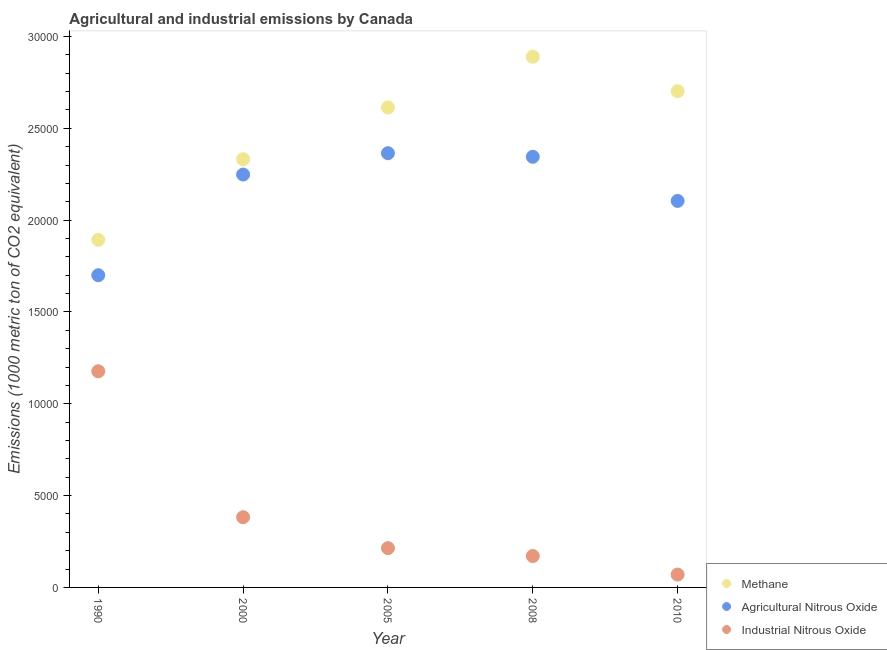How many different coloured dotlines are there?
Your answer should be compact. 3. What is the amount of methane emissions in 2005?
Make the answer very short. 2.61e+04. Across all years, what is the maximum amount of agricultural nitrous oxide emissions?
Your response must be concise. 2.36e+04. Across all years, what is the minimum amount of agricultural nitrous oxide emissions?
Provide a short and direct response. 1.70e+04. In which year was the amount of methane emissions maximum?
Provide a succinct answer. 2008. What is the total amount of industrial nitrous oxide emissions in the graph?
Your answer should be very brief. 2.01e+04. What is the difference between the amount of industrial nitrous oxide emissions in 2000 and that in 2010?
Provide a succinct answer. 3122.5. What is the difference between the amount of industrial nitrous oxide emissions in 1990 and the amount of agricultural nitrous oxide emissions in 2000?
Provide a succinct answer. -1.07e+04. What is the average amount of methane emissions per year?
Make the answer very short. 2.49e+04. In the year 2010, what is the difference between the amount of methane emissions and amount of industrial nitrous oxide emissions?
Your answer should be compact. 2.63e+04. What is the ratio of the amount of industrial nitrous oxide emissions in 2008 to that in 2010?
Keep it short and to the point. 2.44. Is the difference between the amount of agricultural nitrous oxide emissions in 2005 and 2010 greater than the difference between the amount of industrial nitrous oxide emissions in 2005 and 2010?
Ensure brevity in your answer.  Yes. What is the difference between the highest and the second highest amount of agricultural nitrous oxide emissions?
Make the answer very short. 193.7. What is the difference between the highest and the lowest amount of industrial nitrous oxide emissions?
Provide a succinct answer. 1.11e+04. In how many years, is the amount of industrial nitrous oxide emissions greater than the average amount of industrial nitrous oxide emissions taken over all years?
Your answer should be compact. 1. Is the sum of the amount of methane emissions in 2005 and 2010 greater than the maximum amount of industrial nitrous oxide emissions across all years?
Provide a succinct answer. Yes. Does the amount of industrial nitrous oxide emissions monotonically increase over the years?
Ensure brevity in your answer.  No. Is the amount of agricultural nitrous oxide emissions strictly greater than the amount of industrial nitrous oxide emissions over the years?
Offer a very short reply. Yes. How many years are there in the graph?
Make the answer very short. 5. What is the title of the graph?
Keep it short and to the point. Agricultural and industrial emissions by Canada. Does "Social Insurance" appear as one of the legend labels in the graph?
Make the answer very short. No. What is the label or title of the Y-axis?
Make the answer very short. Emissions (1000 metric ton of CO2 equivalent). What is the Emissions (1000 metric ton of CO2 equivalent) in Methane in 1990?
Your answer should be very brief. 1.89e+04. What is the Emissions (1000 metric ton of CO2 equivalent) of Agricultural Nitrous Oxide in 1990?
Make the answer very short. 1.70e+04. What is the Emissions (1000 metric ton of CO2 equivalent) of Industrial Nitrous Oxide in 1990?
Ensure brevity in your answer.  1.18e+04. What is the Emissions (1000 metric ton of CO2 equivalent) of Methane in 2000?
Ensure brevity in your answer.  2.33e+04. What is the Emissions (1000 metric ton of CO2 equivalent) in Agricultural Nitrous Oxide in 2000?
Keep it short and to the point. 2.25e+04. What is the Emissions (1000 metric ton of CO2 equivalent) in Industrial Nitrous Oxide in 2000?
Give a very brief answer. 3823.3. What is the Emissions (1000 metric ton of CO2 equivalent) of Methane in 2005?
Make the answer very short. 2.61e+04. What is the Emissions (1000 metric ton of CO2 equivalent) of Agricultural Nitrous Oxide in 2005?
Your response must be concise. 2.36e+04. What is the Emissions (1000 metric ton of CO2 equivalent) in Industrial Nitrous Oxide in 2005?
Provide a short and direct response. 2139.7. What is the Emissions (1000 metric ton of CO2 equivalent) of Methane in 2008?
Your answer should be compact. 2.89e+04. What is the Emissions (1000 metric ton of CO2 equivalent) in Agricultural Nitrous Oxide in 2008?
Your response must be concise. 2.34e+04. What is the Emissions (1000 metric ton of CO2 equivalent) of Industrial Nitrous Oxide in 2008?
Make the answer very short. 1709.6. What is the Emissions (1000 metric ton of CO2 equivalent) of Methane in 2010?
Ensure brevity in your answer.  2.70e+04. What is the Emissions (1000 metric ton of CO2 equivalent) in Agricultural Nitrous Oxide in 2010?
Offer a terse response. 2.10e+04. What is the Emissions (1000 metric ton of CO2 equivalent) in Industrial Nitrous Oxide in 2010?
Keep it short and to the point. 700.8. Across all years, what is the maximum Emissions (1000 metric ton of CO2 equivalent) of Methane?
Your answer should be compact. 2.89e+04. Across all years, what is the maximum Emissions (1000 metric ton of CO2 equivalent) in Agricultural Nitrous Oxide?
Keep it short and to the point. 2.36e+04. Across all years, what is the maximum Emissions (1000 metric ton of CO2 equivalent) in Industrial Nitrous Oxide?
Provide a short and direct response. 1.18e+04. Across all years, what is the minimum Emissions (1000 metric ton of CO2 equivalent) of Methane?
Your answer should be compact. 1.89e+04. Across all years, what is the minimum Emissions (1000 metric ton of CO2 equivalent) of Agricultural Nitrous Oxide?
Keep it short and to the point. 1.70e+04. Across all years, what is the minimum Emissions (1000 metric ton of CO2 equivalent) in Industrial Nitrous Oxide?
Make the answer very short. 700.8. What is the total Emissions (1000 metric ton of CO2 equivalent) of Methane in the graph?
Offer a very short reply. 1.24e+05. What is the total Emissions (1000 metric ton of CO2 equivalent) of Agricultural Nitrous Oxide in the graph?
Offer a very short reply. 1.08e+05. What is the total Emissions (1000 metric ton of CO2 equivalent) in Industrial Nitrous Oxide in the graph?
Provide a succinct answer. 2.01e+04. What is the difference between the Emissions (1000 metric ton of CO2 equivalent) of Methane in 1990 and that in 2000?
Your answer should be compact. -4391.7. What is the difference between the Emissions (1000 metric ton of CO2 equivalent) in Agricultural Nitrous Oxide in 1990 and that in 2000?
Provide a short and direct response. -5481.4. What is the difference between the Emissions (1000 metric ton of CO2 equivalent) of Industrial Nitrous Oxide in 1990 and that in 2000?
Ensure brevity in your answer.  7946.7. What is the difference between the Emissions (1000 metric ton of CO2 equivalent) of Methane in 1990 and that in 2005?
Keep it short and to the point. -7210.8. What is the difference between the Emissions (1000 metric ton of CO2 equivalent) of Agricultural Nitrous Oxide in 1990 and that in 2005?
Give a very brief answer. -6642.6. What is the difference between the Emissions (1000 metric ton of CO2 equivalent) in Industrial Nitrous Oxide in 1990 and that in 2005?
Make the answer very short. 9630.3. What is the difference between the Emissions (1000 metric ton of CO2 equivalent) of Methane in 1990 and that in 2008?
Ensure brevity in your answer.  -9973.1. What is the difference between the Emissions (1000 metric ton of CO2 equivalent) in Agricultural Nitrous Oxide in 1990 and that in 2008?
Keep it short and to the point. -6448.9. What is the difference between the Emissions (1000 metric ton of CO2 equivalent) in Industrial Nitrous Oxide in 1990 and that in 2008?
Provide a short and direct response. 1.01e+04. What is the difference between the Emissions (1000 metric ton of CO2 equivalent) of Methane in 1990 and that in 2010?
Your answer should be very brief. -8095.8. What is the difference between the Emissions (1000 metric ton of CO2 equivalent) in Agricultural Nitrous Oxide in 1990 and that in 2010?
Your response must be concise. -4045.7. What is the difference between the Emissions (1000 metric ton of CO2 equivalent) of Industrial Nitrous Oxide in 1990 and that in 2010?
Offer a terse response. 1.11e+04. What is the difference between the Emissions (1000 metric ton of CO2 equivalent) of Methane in 2000 and that in 2005?
Provide a succinct answer. -2819.1. What is the difference between the Emissions (1000 metric ton of CO2 equivalent) of Agricultural Nitrous Oxide in 2000 and that in 2005?
Your answer should be very brief. -1161.2. What is the difference between the Emissions (1000 metric ton of CO2 equivalent) of Industrial Nitrous Oxide in 2000 and that in 2005?
Ensure brevity in your answer.  1683.6. What is the difference between the Emissions (1000 metric ton of CO2 equivalent) of Methane in 2000 and that in 2008?
Provide a short and direct response. -5581.4. What is the difference between the Emissions (1000 metric ton of CO2 equivalent) of Agricultural Nitrous Oxide in 2000 and that in 2008?
Ensure brevity in your answer.  -967.5. What is the difference between the Emissions (1000 metric ton of CO2 equivalent) in Industrial Nitrous Oxide in 2000 and that in 2008?
Provide a succinct answer. 2113.7. What is the difference between the Emissions (1000 metric ton of CO2 equivalent) of Methane in 2000 and that in 2010?
Give a very brief answer. -3704.1. What is the difference between the Emissions (1000 metric ton of CO2 equivalent) in Agricultural Nitrous Oxide in 2000 and that in 2010?
Provide a short and direct response. 1435.7. What is the difference between the Emissions (1000 metric ton of CO2 equivalent) in Industrial Nitrous Oxide in 2000 and that in 2010?
Provide a short and direct response. 3122.5. What is the difference between the Emissions (1000 metric ton of CO2 equivalent) in Methane in 2005 and that in 2008?
Ensure brevity in your answer.  -2762.3. What is the difference between the Emissions (1000 metric ton of CO2 equivalent) in Agricultural Nitrous Oxide in 2005 and that in 2008?
Keep it short and to the point. 193.7. What is the difference between the Emissions (1000 metric ton of CO2 equivalent) of Industrial Nitrous Oxide in 2005 and that in 2008?
Provide a short and direct response. 430.1. What is the difference between the Emissions (1000 metric ton of CO2 equivalent) in Methane in 2005 and that in 2010?
Provide a short and direct response. -885. What is the difference between the Emissions (1000 metric ton of CO2 equivalent) in Agricultural Nitrous Oxide in 2005 and that in 2010?
Offer a very short reply. 2596.9. What is the difference between the Emissions (1000 metric ton of CO2 equivalent) in Industrial Nitrous Oxide in 2005 and that in 2010?
Your response must be concise. 1438.9. What is the difference between the Emissions (1000 metric ton of CO2 equivalent) in Methane in 2008 and that in 2010?
Ensure brevity in your answer.  1877.3. What is the difference between the Emissions (1000 metric ton of CO2 equivalent) of Agricultural Nitrous Oxide in 2008 and that in 2010?
Keep it short and to the point. 2403.2. What is the difference between the Emissions (1000 metric ton of CO2 equivalent) in Industrial Nitrous Oxide in 2008 and that in 2010?
Ensure brevity in your answer.  1008.8. What is the difference between the Emissions (1000 metric ton of CO2 equivalent) in Methane in 1990 and the Emissions (1000 metric ton of CO2 equivalent) in Agricultural Nitrous Oxide in 2000?
Make the answer very short. -3557.3. What is the difference between the Emissions (1000 metric ton of CO2 equivalent) in Methane in 1990 and the Emissions (1000 metric ton of CO2 equivalent) in Industrial Nitrous Oxide in 2000?
Your answer should be very brief. 1.51e+04. What is the difference between the Emissions (1000 metric ton of CO2 equivalent) in Agricultural Nitrous Oxide in 1990 and the Emissions (1000 metric ton of CO2 equivalent) in Industrial Nitrous Oxide in 2000?
Offer a very short reply. 1.32e+04. What is the difference between the Emissions (1000 metric ton of CO2 equivalent) of Methane in 1990 and the Emissions (1000 metric ton of CO2 equivalent) of Agricultural Nitrous Oxide in 2005?
Offer a very short reply. -4718.5. What is the difference between the Emissions (1000 metric ton of CO2 equivalent) in Methane in 1990 and the Emissions (1000 metric ton of CO2 equivalent) in Industrial Nitrous Oxide in 2005?
Ensure brevity in your answer.  1.68e+04. What is the difference between the Emissions (1000 metric ton of CO2 equivalent) in Agricultural Nitrous Oxide in 1990 and the Emissions (1000 metric ton of CO2 equivalent) in Industrial Nitrous Oxide in 2005?
Provide a short and direct response. 1.49e+04. What is the difference between the Emissions (1000 metric ton of CO2 equivalent) in Methane in 1990 and the Emissions (1000 metric ton of CO2 equivalent) in Agricultural Nitrous Oxide in 2008?
Offer a very short reply. -4524.8. What is the difference between the Emissions (1000 metric ton of CO2 equivalent) in Methane in 1990 and the Emissions (1000 metric ton of CO2 equivalent) in Industrial Nitrous Oxide in 2008?
Your answer should be very brief. 1.72e+04. What is the difference between the Emissions (1000 metric ton of CO2 equivalent) in Agricultural Nitrous Oxide in 1990 and the Emissions (1000 metric ton of CO2 equivalent) in Industrial Nitrous Oxide in 2008?
Your answer should be compact. 1.53e+04. What is the difference between the Emissions (1000 metric ton of CO2 equivalent) in Methane in 1990 and the Emissions (1000 metric ton of CO2 equivalent) in Agricultural Nitrous Oxide in 2010?
Your answer should be very brief. -2121.6. What is the difference between the Emissions (1000 metric ton of CO2 equivalent) in Methane in 1990 and the Emissions (1000 metric ton of CO2 equivalent) in Industrial Nitrous Oxide in 2010?
Your answer should be compact. 1.82e+04. What is the difference between the Emissions (1000 metric ton of CO2 equivalent) in Agricultural Nitrous Oxide in 1990 and the Emissions (1000 metric ton of CO2 equivalent) in Industrial Nitrous Oxide in 2010?
Ensure brevity in your answer.  1.63e+04. What is the difference between the Emissions (1000 metric ton of CO2 equivalent) in Methane in 2000 and the Emissions (1000 metric ton of CO2 equivalent) in Agricultural Nitrous Oxide in 2005?
Offer a very short reply. -326.8. What is the difference between the Emissions (1000 metric ton of CO2 equivalent) in Methane in 2000 and the Emissions (1000 metric ton of CO2 equivalent) in Industrial Nitrous Oxide in 2005?
Your response must be concise. 2.12e+04. What is the difference between the Emissions (1000 metric ton of CO2 equivalent) of Agricultural Nitrous Oxide in 2000 and the Emissions (1000 metric ton of CO2 equivalent) of Industrial Nitrous Oxide in 2005?
Your response must be concise. 2.03e+04. What is the difference between the Emissions (1000 metric ton of CO2 equivalent) in Methane in 2000 and the Emissions (1000 metric ton of CO2 equivalent) in Agricultural Nitrous Oxide in 2008?
Give a very brief answer. -133.1. What is the difference between the Emissions (1000 metric ton of CO2 equivalent) of Methane in 2000 and the Emissions (1000 metric ton of CO2 equivalent) of Industrial Nitrous Oxide in 2008?
Provide a short and direct response. 2.16e+04. What is the difference between the Emissions (1000 metric ton of CO2 equivalent) of Agricultural Nitrous Oxide in 2000 and the Emissions (1000 metric ton of CO2 equivalent) of Industrial Nitrous Oxide in 2008?
Provide a succinct answer. 2.08e+04. What is the difference between the Emissions (1000 metric ton of CO2 equivalent) in Methane in 2000 and the Emissions (1000 metric ton of CO2 equivalent) in Agricultural Nitrous Oxide in 2010?
Offer a very short reply. 2270.1. What is the difference between the Emissions (1000 metric ton of CO2 equivalent) of Methane in 2000 and the Emissions (1000 metric ton of CO2 equivalent) of Industrial Nitrous Oxide in 2010?
Your response must be concise. 2.26e+04. What is the difference between the Emissions (1000 metric ton of CO2 equivalent) in Agricultural Nitrous Oxide in 2000 and the Emissions (1000 metric ton of CO2 equivalent) in Industrial Nitrous Oxide in 2010?
Your answer should be very brief. 2.18e+04. What is the difference between the Emissions (1000 metric ton of CO2 equivalent) of Methane in 2005 and the Emissions (1000 metric ton of CO2 equivalent) of Agricultural Nitrous Oxide in 2008?
Make the answer very short. 2686. What is the difference between the Emissions (1000 metric ton of CO2 equivalent) of Methane in 2005 and the Emissions (1000 metric ton of CO2 equivalent) of Industrial Nitrous Oxide in 2008?
Offer a very short reply. 2.44e+04. What is the difference between the Emissions (1000 metric ton of CO2 equivalent) of Agricultural Nitrous Oxide in 2005 and the Emissions (1000 metric ton of CO2 equivalent) of Industrial Nitrous Oxide in 2008?
Offer a very short reply. 2.19e+04. What is the difference between the Emissions (1000 metric ton of CO2 equivalent) of Methane in 2005 and the Emissions (1000 metric ton of CO2 equivalent) of Agricultural Nitrous Oxide in 2010?
Provide a short and direct response. 5089.2. What is the difference between the Emissions (1000 metric ton of CO2 equivalent) in Methane in 2005 and the Emissions (1000 metric ton of CO2 equivalent) in Industrial Nitrous Oxide in 2010?
Offer a very short reply. 2.54e+04. What is the difference between the Emissions (1000 metric ton of CO2 equivalent) of Agricultural Nitrous Oxide in 2005 and the Emissions (1000 metric ton of CO2 equivalent) of Industrial Nitrous Oxide in 2010?
Ensure brevity in your answer.  2.29e+04. What is the difference between the Emissions (1000 metric ton of CO2 equivalent) in Methane in 2008 and the Emissions (1000 metric ton of CO2 equivalent) in Agricultural Nitrous Oxide in 2010?
Offer a very short reply. 7851.5. What is the difference between the Emissions (1000 metric ton of CO2 equivalent) of Methane in 2008 and the Emissions (1000 metric ton of CO2 equivalent) of Industrial Nitrous Oxide in 2010?
Keep it short and to the point. 2.82e+04. What is the difference between the Emissions (1000 metric ton of CO2 equivalent) in Agricultural Nitrous Oxide in 2008 and the Emissions (1000 metric ton of CO2 equivalent) in Industrial Nitrous Oxide in 2010?
Ensure brevity in your answer.  2.27e+04. What is the average Emissions (1000 metric ton of CO2 equivalent) in Methane per year?
Keep it short and to the point. 2.49e+04. What is the average Emissions (1000 metric ton of CO2 equivalent) of Agricultural Nitrous Oxide per year?
Your answer should be very brief. 2.15e+04. What is the average Emissions (1000 metric ton of CO2 equivalent) in Industrial Nitrous Oxide per year?
Offer a terse response. 4028.68. In the year 1990, what is the difference between the Emissions (1000 metric ton of CO2 equivalent) in Methane and Emissions (1000 metric ton of CO2 equivalent) in Agricultural Nitrous Oxide?
Make the answer very short. 1924.1. In the year 1990, what is the difference between the Emissions (1000 metric ton of CO2 equivalent) of Methane and Emissions (1000 metric ton of CO2 equivalent) of Industrial Nitrous Oxide?
Keep it short and to the point. 7153.5. In the year 1990, what is the difference between the Emissions (1000 metric ton of CO2 equivalent) of Agricultural Nitrous Oxide and Emissions (1000 metric ton of CO2 equivalent) of Industrial Nitrous Oxide?
Ensure brevity in your answer.  5229.4. In the year 2000, what is the difference between the Emissions (1000 metric ton of CO2 equivalent) of Methane and Emissions (1000 metric ton of CO2 equivalent) of Agricultural Nitrous Oxide?
Provide a short and direct response. 834.4. In the year 2000, what is the difference between the Emissions (1000 metric ton of CO2 equivalent) of Methane and Emissions (1000 metric ton of CO2 equivalent) of Industrial Nitrous Oxide?
Offer a very short reply. 1.95e+04. In the year 2000, what is the difference between the Emissions (1000 metric ton of CO2 equivalent) in Agricultural Nitrous Oxide and Emissions (1000 metric ton of CO2 equivalent) in Industrial Nitrous Oxide?
Make the answer very short. 1.87e+04. In the year 2005, what is the difference between the Emissions (1000 metric ton of CO2 equivalent) in Methane and Emissions (1000 metric ton of CO2 equivalent) in Agricultural Nitrous Oxide?
Your response must be concise. 2492.3. In the year 2005, what is the difference between the Emissions (1000 metric ton of CO2 equivalent) in Methane and Emissions (1000 metric ton of CO2 equivalent) in Industrial Nitrous Oxide?
Make the answer very short. 2.40e+04. In the year 2005, what is the difference between the Emissions (1000 metric ton of CO2 equivalent) of Agricultural Nitrous Oxide and Emissions (1000 metric ton of CO2 equivalent) of Industrial Nitrous Oxide?
Your answer should be very brief. 2.15e+04. In the year 2008, what is the difference between the Emissions (1000 metric ton of CO2 equivalent) in Methane and Emissions (1000 metric ton of CO2 equivalent) in Agricultural Nitrous Oxide?
Make the answer very short. 5448.3. In the year 2008, what is the difference between the Emissions (1000 metric ton of CO2 equivalent) of Methane and Emissions (1000 metric ton of CO2 equivalent) of Industrial Nitrous Oxide?
Your response must be concise. 2.72e+04. In the year 2008, what is the difference between the Emissions (1000 metric ton of CO2 equivalent) of Agricultural Nitrous Oxide and Emissions (1000 metric ton of CO2 equivalent) of Industrial Nitrous Oxide?
Make the answer very short. 2.17e+04. In the year 2010, what is the difference between the Emissions (1000 metric ton of CO2 equivalent) of Methane and Emissions (1000 metric ton of CO2 equivalent) of Agricultural Nitrous Oxide?
Provide a succinct answer. 5974.2. In the year 2010, what is the difference between the Emissions (1000 metric ton of CO2 equivalent) in Methane and Emissions (1000 metric ton of CO2 equivalent) in Industrial Nitrous Oxide?
Make the answer very short. 2.63e+04. In the year 2010, what is the difference between the Emissions (1000 metric ton of CO2 equivalent) of Agricultural Nitrous Oxide and Emissions (1000 metric ton of CO2 equivalent) of Industrial Nitrous Oxide?
Your response must be concise. 2.03e+04. What is the ratio of the Emissions (1000 metric ton of CO2 equivalent) of Methane in 1990 to that in 2000?
Your answer should be compact. 0.81. What is the ratio of the Emissions (1000 metric ton of CO2 equivalent) of Agricultural Nitrous Oxide in 1990 to that in 2000?
Make the answer very short. 0.76. What is the ratio of the Emissions (1000 metric ton of CO2 equivalent) of Industrial Nitrous Oxide in 1990 to that in 2000?
Make the answer very short. 3.08. What is the ratio of the Emissions (1000 metric ton of CO2 equivalent) of Methane in 1990 to that in 2005?
Your answer should be compact. 0.72. What is the ratio of the Emissions (1000 metric ton of CO2 equivalent) in Agricultural Nitrous Oxide in 1990 to that in 2005?
Keep it short and to the point. 0.72. What is the ratio of the Emissions (1000 metric ton of CO2 equivalent) of Industrial Nitrous Oxide in 1990 to that in 2005?
Provide a short and direct response. 5.5. What is the ratio of the Emissions (1000 metric ton of CO2 equivalent) of Methane in 1990 to that in 2008?
Make the answer very short. 0.65. What is the ratio of the Emissions (1000 metric ton of CO2 equivalent) of Agricultural Nitrous Oxide in 1990 to that in 2008?
Your response must be concise. 0.72. What is the ratio of the Emissions (1000 metric ton of CO2 equivalent) in Industrial Nitrous Oxide in 1990 to that in 2008?
Your answer should be very brief. 6.88. What is the ratio of the Emissions (1000 metric ton of CO2 equivalent) of Methane in 1990 to that in 2010?
Your response must be concise. 0.7. What is the ratio of the Emissions (1000 metric ton of CO2 equivalent) in Agricultural Nitrous Oxide in 1990 to that in 2010?
Offer a very short reply. 0.81. What is the ratio of the Emissions (1000 metric ton of CO2 equivalent) in Industrial Nitrous Oxide in 1990 to that in 2010?
Keep it short and to the point. 16.8. What is the ratio of the Emissions (1000 metric ton of CO2 equivalent) of Methane in 2000 to that in 2005?
Make the answer very short. 0.89. What is the ratio of the Emissions (1000 metric ton of CO2 equivalent) of Agricultural Nitrous Oxide in 2000 to that in 2005?
Your answer should be compact. 0.95. What is the ratio of the Emissions (1000 metric ton of CO2 equivalent) of Industrial Nitrous Oxide in 2000 to that in 2005?
Provide a succinct answer. 1.79. What is the ratio of the Emissions (1000 metric ton of CO2 equivalent) of Methane in 2000 to that in 2008?
Ensure brevity in your answer.  0.81. What is the ratio of the Emissions (1000 metric ton of CO2 equivalent) of Agricultural Nitrous Oxide in 2000 to that in 2008?
Offer a very short reply. 0.96. What is the ratio of the Emissions (1000 metric ton of CO2 equivalent) of Industrial Nitrous Oxide in 2000 to that in 2008?
Ensure brevity in your answer.  2.24. What is the ratio of the Emissions (1000 metric ton of CO2 equivalent) in Methane in 2000 to that in 2010?
Provide a short and direct response. 0.86. What is the ratio of the Emissions (1000 metric ton of CO2 equivalent) of Agricultural Nitrous Oxide in 2000 to that in 2010?
Your answer should be very brief. 1.07. What is the ratio of the Emissions (1000 metric ton of CO2 equivalent) of Industrial Nitrous Oxide in 2000 to that in 2010?
Keep it short and to the point. 5.46. What is the ratio of the Emissions (1000 metric ton of CO2 equivalent) in Methane in 2005 to that in 2008?
Provide a succinct answer. 0.9. What is the ratio of the Emissions (1000 metric ton of CO2 equivalent) in Agricultural Nitrous Oxide in 2005 to that in 2008?
Offer a terse response. 1.01. What is the ratio of the Emissions (1000 metric ton of CO2 equivalent) of Industrial Nitrous Oxide in 2005 to that in 2008?
Ensure brevity in your answer.  1.25. What is the ratio of the Emissions (1000 metric ton of CO2 equivalent) in Methane in 2005 to that in 2010?
Keep it short and to the point. 0.97. What is the ratio of the Emissions (1000 metric ton of CO2 equivalent) of Agricultural Nitrous Oxide in 2005 to that in 2010?
Your response must be concise. 1.12. What is the ratio of the Emissions (1000 metric ton of CO2 equivalent) in Industrial Nitrous Oxide in 2005 to that in 2010?
Make the answer very short. 3.05. What is the ratio of the Emissions (1000 metric ton of CO2 equivalent) of Methane in 2008 to that in 2010?
Give a very brief answer. 1.07. What is the ratio of the Emissions (1000 metric ton of CO2 equivalent) of Agricultural Nitrous Oxide in 2008 to that in 2010?
Keep it short and to the point. 1.11. What is the ratio of the Emissions (1000 metric ton of CO2 equivalent) in Industrial Nitrous Oxide in 2008 to that in 2010?
Your response must be concise. 2.44. What is the difference between the highest and the second highest Emissions (1000 metric ton of CO2 equivalent) in Methane?
Keep it short and to the point. 1877.3. What is the difference between the highest and the second highest Emissions (1000 metric ton of CO2 equivalent) in Agricultural Nitrous Oxide?
Keep it short and to the point. 193.7. What is the difference between the highest and the second highest Emissions (1000 metric ton of CO2 equivalent) in Industrial Nitrous Oxide?
Make the answer very short. 7946.7. What is the difference between the highest and the lowest Emissions (1000 metric ton of CO2 equivalent) of Methane?
Offer a very short reply. 9973.1. What is the difference between the highest and the lowest Emissions (1000 metric ton of CO2 equivalent) of Agricultural Nitrous Oxide?
Offer a very short reply. 6642.6. What is the difference between the highest and the lowest Emissions (1000 metric ton of CO2 equivalent) in Industrial Nitrous Oxide?
Your answer should be very brief. 1.11e+04. 